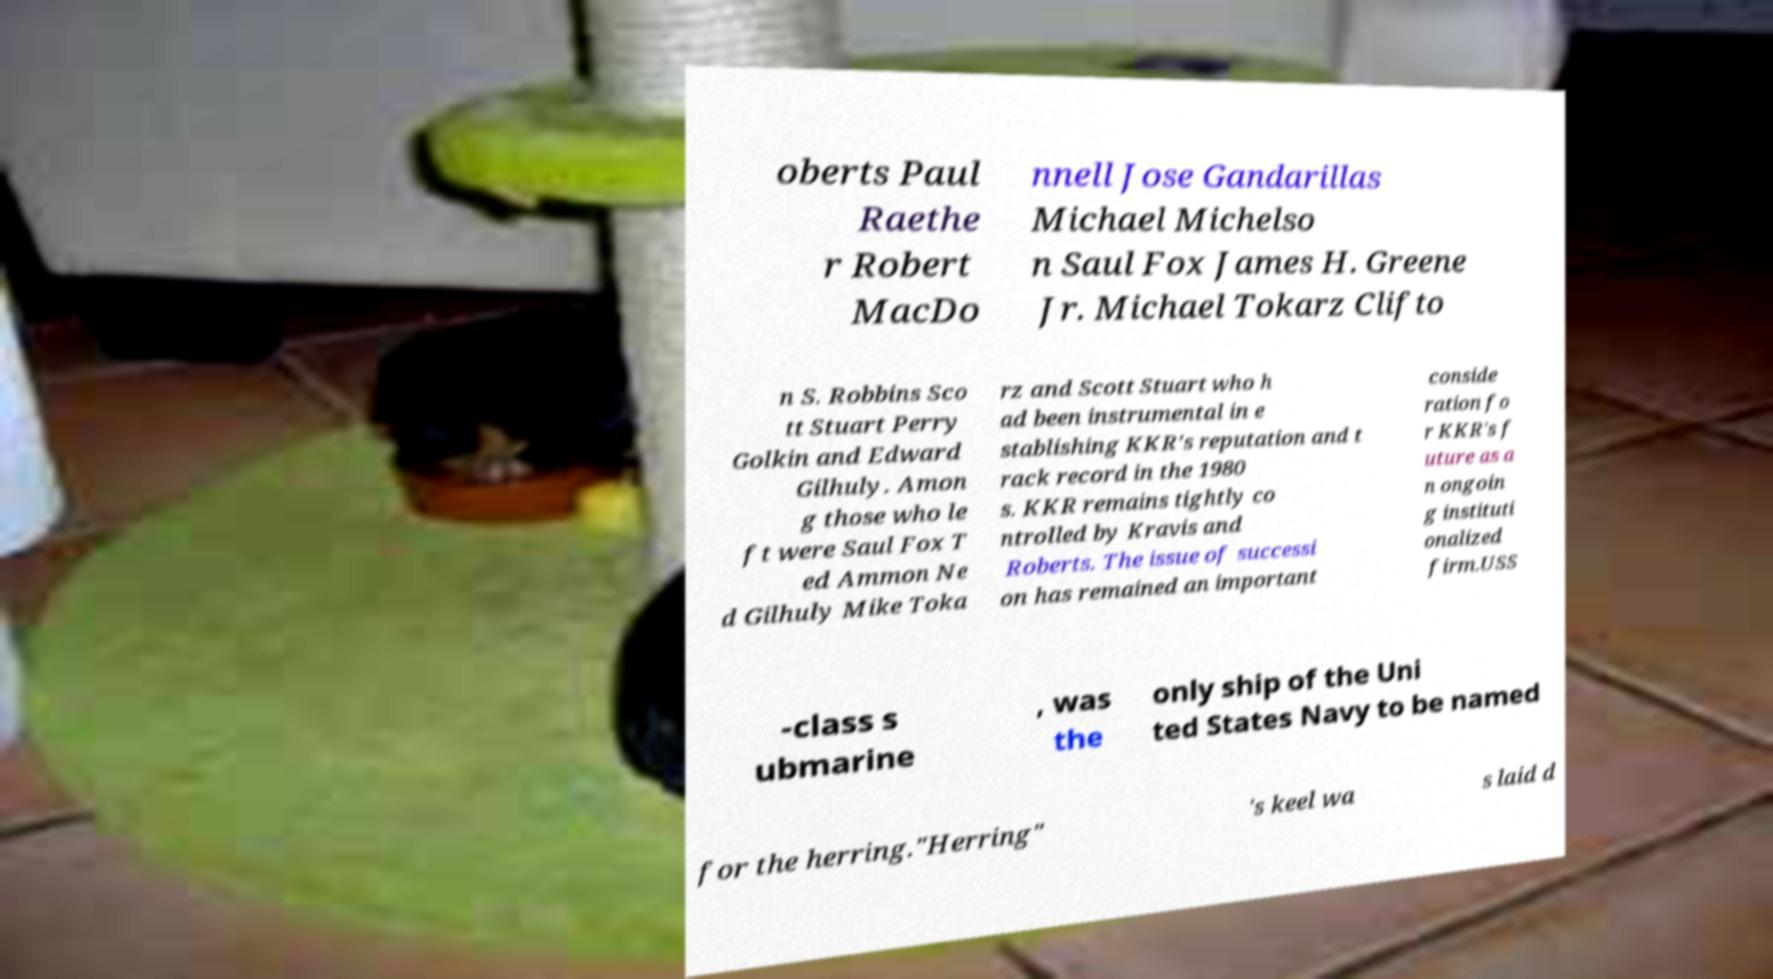I need the written content from this picture converted into text. Can you do that? oberts Paul Raethe r Robert MacDo nnell Jose Gandarillas Michael Michelso n Saul Fox James H. Greene Jr. Michael Tokarz Clifto n S. Robbins Sco tt Stuart Perry Golkin and Edward Gilhuly. Amon g those who le ft were Saul Fox T ed Ammon Ne d Gilhuly Mike Toka rz and Scott Stuart who h ad been instrumental in e stablishing KKR's reputation and t rack record in the 1980 s. KKR remains tightly co ntrolled by Kravis and Roberts. The issue of successi on has remained an important conside ration fo r KKR's f uture as a n ongoin g instituti onalized firm.USS -class s ubmarine , was the only ship of the Uni ted States Navy to be named for the herring."Herring" 's keel wa s laid d 